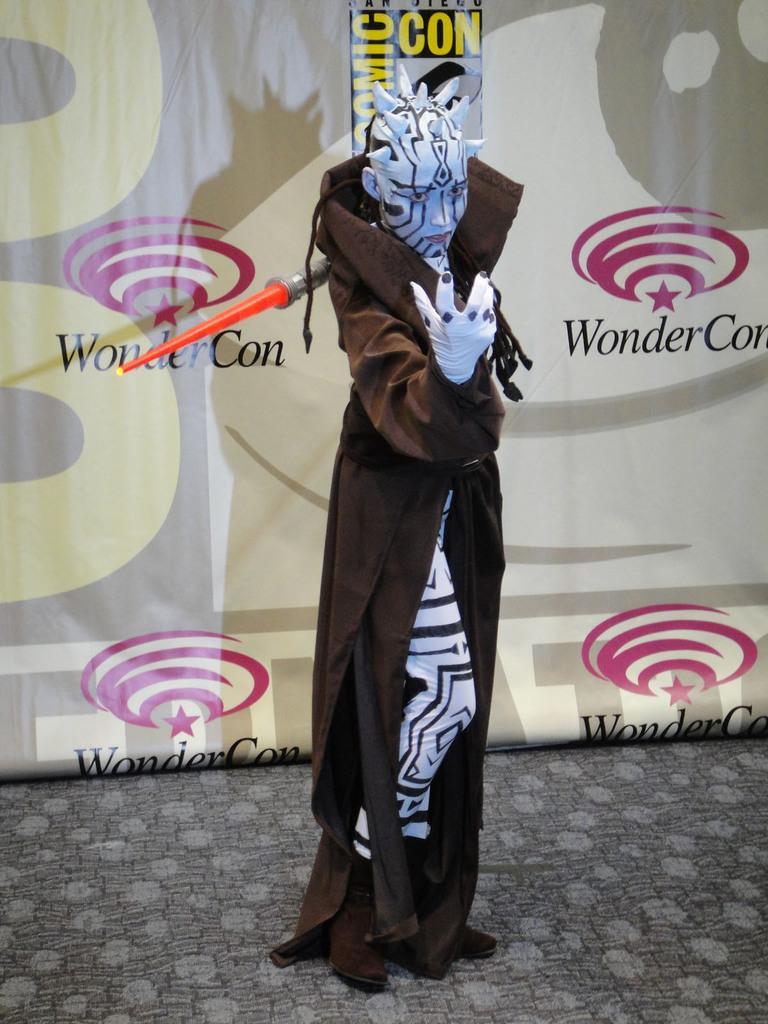Describe this image in one or two sentences. In this image we can see a person with a costume. Near to the person there is an object. In the back there is a banner with text and logos. 